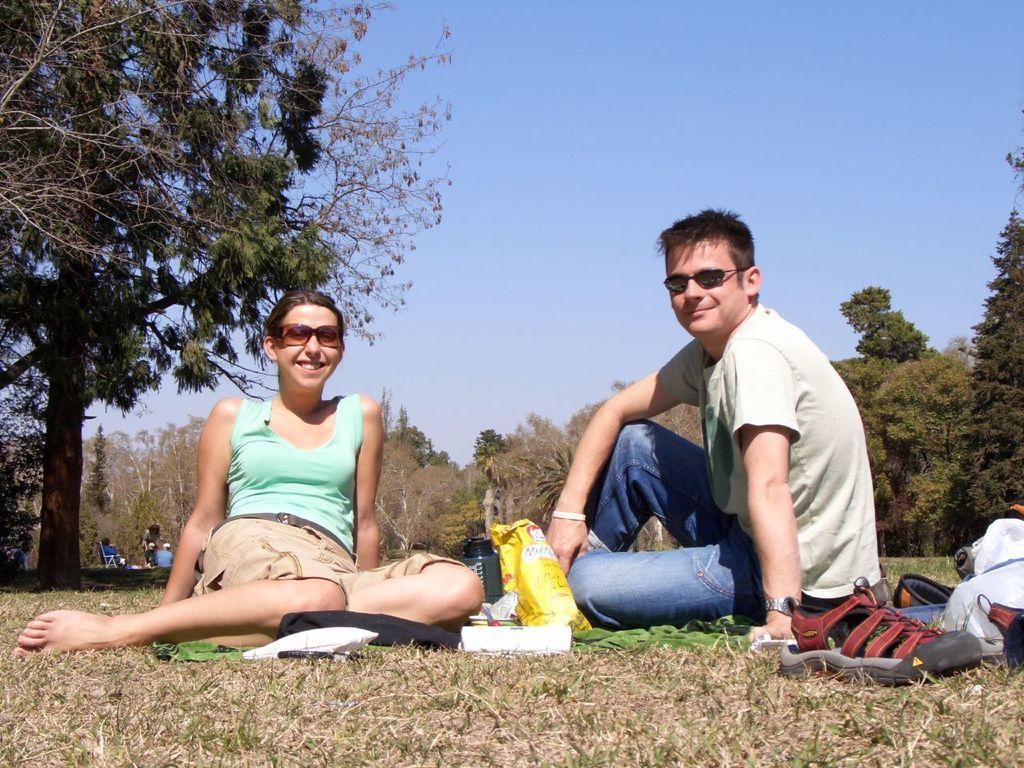How would you summarize this image in a sentence or two? In this image we can see two people sitting and posing for a photo and there are some objects like bottle, food items and some things and on the right side we can see a shoe and some objects on the ground. In the background, we can see some trees and some people and at the top we can see the sky. 